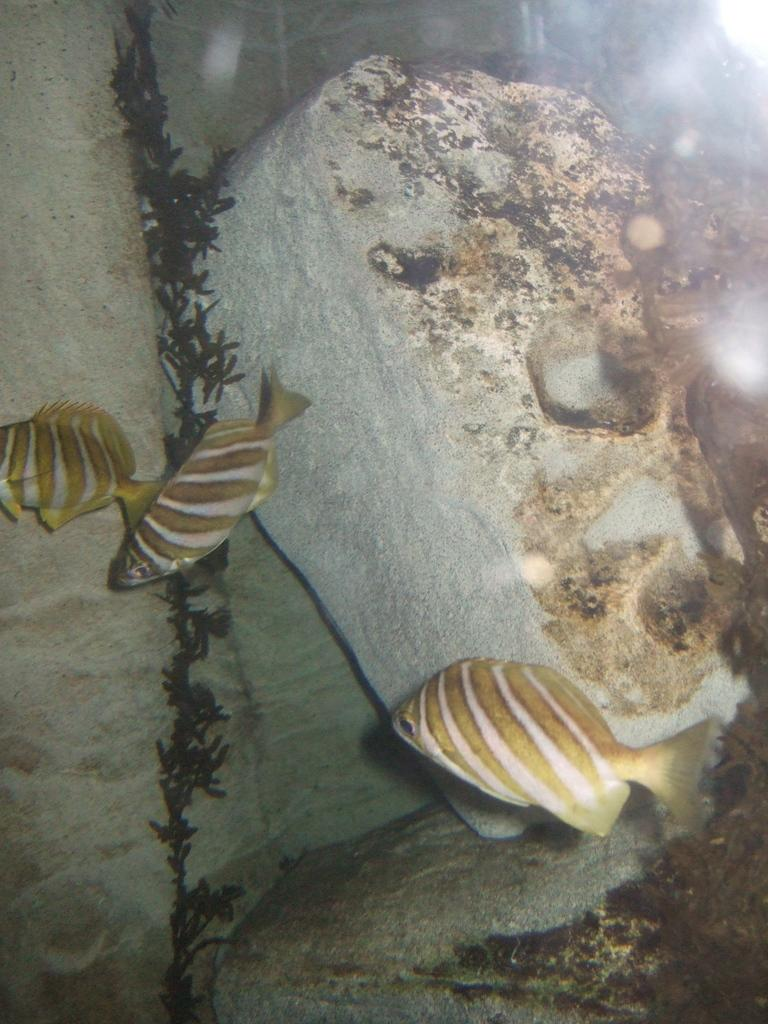How many tiger barb fishes are visible in the water? There are 3 tiger barb fishes in the water. What else can be seen in the image besides the fishes? There is a stone at the back of the image. How does the bubble affect the movement of the tiger barb fishes in the image? There is no bubble present in the image, so it does not affect the movement of the tiger barb fishes. 